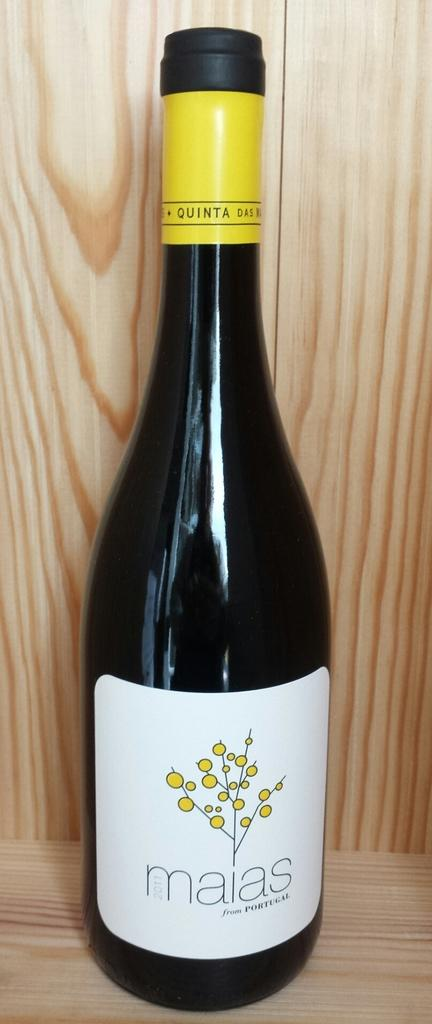<image>
Provide a brief description of the given image. A bottle of maias wine from Portugal has a yellow band around the neck. 